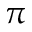Convert formula to latex. <formula><loc_0><loc_0><loc_500><loc_500>\pi</formula> 